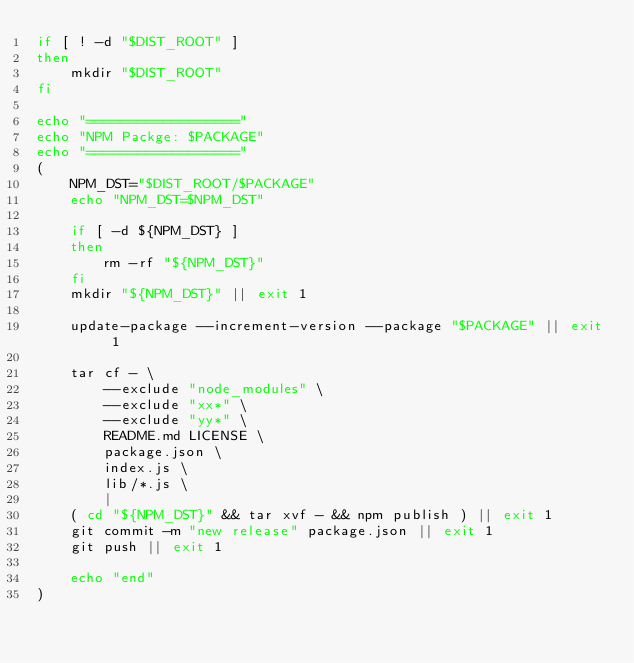Convert code to text. <code><loc_0><loc_0><loc_500><loc_500><_Bash_>if [ ! -d "$DIST_ROOT" ]
then
    mkdir "$DIST_ROOT"
fi

echo "=================="
echo "NPM Packge: $PACKAGE"
echo "=================="
(
    NPM_DST="$DIST_ROOT/$PACKAGE"
    echo "NPM_DST=$NPM_DST"

    if [ -d ${NPM_DST} ]
    then
        rm -rf "${NPM_DST}"
    fi
    mkdir "${NPM_DST}" || exit 1

    update-package --increment-version --package "$PACKAGE" || exit 1

    tar cf - \
        --exclude "node_modules" \
        --exclude "xx*" \
        --exclude "yy*" \
        README.md LICENSE \
        package.json \
        index.js \
        lib/*.js \
        |
    ( cd "${NPM_DST}" && tar xvf - && npm publish ) || exit 1
    git commit -m "new release" package.json || exit 1
    git push || exit 1

    echo "end"
)
</code> 